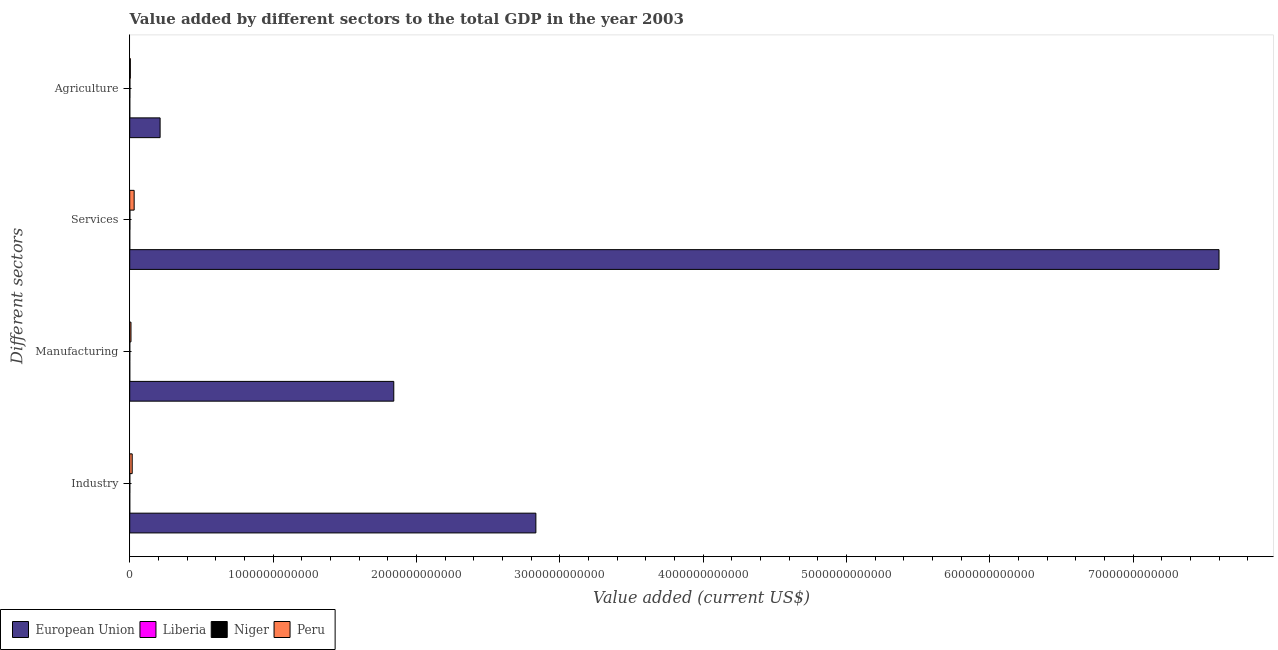Are the number of bars per tick equal to the number of legend labels?
Provide a short and direct response. Yes. What is the label of the 1st group of bars from the top?
Ensure brevity in your answer.  Agriculture. What is the value added by manufacturing sector in Niger?
Offer a very short reply. 1.73e+08. Across all countries, what is the maximum value added by agricultural sector?
Your answer should be very brief. 2.12e+11. Across all countries, what is the minimum value added by agricultural sector?
Your answer should be very brief. 3.01e+08. In which country was the value added by industrial sector minimum?
Your response must be concise. Liberia. What is the total value added by manufacturing sector in the graph?
Make the answer very short. 1.85e+12. What is the difference between the value added by services sector in Peru and that in European Union?
Provide a short and direct response. -7.57e+12. What is the difference between the value added by industrial sector in European Union and the value added by manufacturing sector in Niger?
Keep it short and to the point. 2.83e+12. What is the average value added by agricultural sector per country?
Your answer should be very brief. 5.44e+1. What is the difference between the value added by manufacturing sector and value added by services sector in Peru?
Offer a terse response. -2.21e+1. In how many countries, is the value added by services sector greater than 5400000000000 US$?
Ensure brevity in your answer.  1. What is the ratio of the value added by agricultural sector in Liberia to that in Niger?
Your response must be concise. 0.28. Is the value added by manufacturing sector in Niger less than that in Liberia?
Offer a terse response. No. What is the difference between the highest and the second highest value added by agricultural sector?
Your answer should be very brief. 2.08e+11. What is the difference between the highest and the lowest value added by industrial sector?
Offer a very short reply. 2.83e+12. What does the 3rd bar from the top in Manufacturing represents?
Provide a short and direct response. Liberia. What does the 2nd bar from the bottom in Agriculture represents?
Provide a short and direct response. Liberia. How many countries are there in the graph?
Provide a succinct answer. 4. What is the difference between two consecutive major ticks on the X-axis?
Keep it short and to the point. 1.00e+12. Does the graph contain any zero values?
Your answer should be very brief. No. Does the graph contain grids?
Keep it short and to the point. No. Where does the legend appear in the graph?
Make the answer very short. Bottom left. What is the title of the graph?
Give a very brief answer. Value added by different sectors to the total GDP in the year 2003. Does "OECD members" appear as one of the legend labels in the graph?
Keep it short and to the point. No. What is the label or title of the X-axis?
Provide a succinct answer. Value added (current US$). What is the label or title of the Y-axis?
Your answer should be compact. Different sectors. What is the Value added (current US$) in European Union in Industry?
Offer a terse response. 2.83e+12. What is the Value added (current US$) in Liberia in Industry?
Your answer should be very brief. 1.73e+07. What is the Value added (current US$) of Niger in Industry?
Your response must be concise. 4.68e+08. What is the Value added (current US$) of Peru in Industry?
Provide a succinct answer. 1.73e+1. What is the Value added (current US$) in European Union in Manufacturing?
Offer a terse response. 1.84e+12. What is the Value added (current US$) in Liberia in Manufacturing?
Offer a terse response. 1.69e+07. What is the Value added (current US$) in Niger in Manufacturing?
Your response must be concise. 1.73e+08. What is the Value added (current US$) in Peru in Manufacturing?
Ensure brevity in your answer.  8.81e+09. What is the Value added (current US$) of European Union in Services?
Make the answer very short. 7.60e+12. What is the Value added (current US$) in Liberia in Services?
Provide a short and direct response. 9.90e+07. What is the Value added (current US$) of Niger in Services?
Offer a terse response. 1.18e+09. What is the Value added (current US$) of Peru in Services?
Make the answer very short. 3.09e+1. What is the Value added (current US$) in European Union in Agriculture?
Offer a very short reply. 2.12e+11. What is the Value added (current US$) of Liberia in Agriculture?
Give a very brief answer. 3.01e+08. What is the Value added (current US$) in Niger in Agriculture?
Make the answer very short. 1.08e+09. What is the Value added (current US$) of Peru in Agriculture?
Offer a very short reply. 4.28e+09. Across all Different sectors, what is the maximum Value added (current US$) in European Union?
Keep it short and to the point. 7.60e+12. Across all Different sectors, what is the maximum Value added (current US$) of Liberia?
Your response must be concise. 3.01e+08. Across all Different sectors, what is the maximum Value added (current US$) of Niger?
Your response must be concise. 1.18e+09. Across all Different sectors, what is the maximum Value added (current US$) in Peru?
Ensure brevity in your answer.  3.09e+1. Across all Different sectors, what is the minimum Value added (current US$) of European Union?
Keep it short and to the point. 2.12e+11. Across all Different sectors, what is the minimum Value added (current US$) in Liberia?
Your answer should be very brief. 1.69e+07. Across all Different sectors, what is the minimum Value added (current US$) of Niger?
Your response must be concise. 1.73e+08. Across all Different sectors, what is the minimum Value added (current US$) of Peru?
Provide a short and direct response. 4.28e+09. What is the total Value added (current US$) in European Union in the graph?
Your answer should be compact. 1.25e+13. What is the total Value added (current US$) in Liberia in the graph?
Your response must be concise. 4.34e+08. What is the total Value added (current US$) of Niger in the graph?
Provide a short and direct response. 2.90e+09. What is the total Value added (current US$) in Peru in the graph?
Give a very brief answer. 6.13e+1. What is the difference between the Value added (current US$) in European Union in Industry and that in Manufacturing?
Offer a very short reply. 9.91e+11. What is the difference between the Value added (current US$) of Liberia in Industry and that in Manufacturing?
Keep it short and to the point. 3.84e+05. What is the difference between the Value added (current US$) in Niger in Industry and that in Manufacturing?
Your response must be concise. 2.94e+08. What is the difference between the Value added (current US$) of Peru in Industry and that in Manufacturing?
Give a very brief answer. 8.50e+09. What is the difference between the Value added (current US$) in European Union in Industry and that in Services?
Your answer should be compact. -4.77e+12. What is the difference between the Value added (current US$) in Liberia in Industry and that in Services?
Your response must be concise. -8.17e+07. What is the difference between the Value added (current US$) of Niger in Industry and that in Services?
Your answer should be compact. -7.13e+08. What is the difference between the Value added (current US$) of Peru in Industry and that in Services?
Offer a very short reply. -1.36e+1. What is the difference between the Value added (current US$) of European Union in Industry and that in Agriculture?
Your response must be concise. 2.62e+12. What is the difference between the Value added (current US$) in Liberia in Industry and that in Agriculture?
Offer a terse response. -2.83e+08. What is the difference between the Value added (current US$) in Niger in Industry and that in Agriculture?
Offer a very short reply. -6.15e+08. What is the difference between the Value added (current US$) in Peru in Industry and that in Agriculture?
Make the answer very short. 1.30e+1. What is the difference between the Value added (current US$) of European Union in Manufacturing and that in Services?
Keep it short and to the point. -5.76e+12. What is the difference between the Value added (current US$) of Liberia in Manufacturing and that in Services?
Make the answer very short. -8.21e+07. What is the difference between the Value added (current US$) of Niger in Manufacturing and that in Services?
Keep it short and to the point. -1.01e+09. What is the difference between the Value added (current US$) of Peru in Manufacturing and that in Services?
Your answer should be compact. -2.21e+1. What is the difference between the Value added (current US$) in European Union in Manufacturing and that in Agriculture?
Keep it short and to the point. 1.63e+12. What is the difference between the Value added (current US$) of Liberia in Manufacturing and that in Agriculture?
Your answer should be very brief. -2.84e+08. What is the difference between the Value added (current US$) of Niger in Manufacturing and that in Agriculture?
Your response must be concise. -9.09e+08. What is the difference between the Value added (current US$) in Peru in Manufacturing and that in Agriculture?
Offer a terse response. 4.53e+09. What is the difference between the Value added (current US$) in European Union in Services and that in Agriculture?
Offer a terse response. 7.39e+12. What is the difference between the Value added (current US$) of Liberia in Services and that in Agriculture?
Keep it short and to the point. -2.02e+08. What is the difference between the Value added (current US$) in Niger in Services and that in Agriculture?
Keep it short and to the point. 9.79e+07. What is the difference between the Value added (current US$) in Peru in Services and that in Agriculture?
Make the answer very short. 2.66e+1. What is the difference between the Value added (current US$) in European Union in Industry and the Value added (current US$) in Liberia in Manufacturing?
Keep it short and to the point. 2.83e+12. What is the difference between the Value added (current US$) in European Union in Industry and the Value added (current US$) in Niger in Manufacturing?
Your answer should be compact. 2.83e+12. What is the difference between the Value added (current US$) in European Union in Industry and the Value added (current US$) in Peru in Manufacturing?
Offer a terse response. 2.82e+12. What is the difference between the Value added (current US$) in Liberia in Industry and the Value added (current US$) in Niger in Manufacturing?
Provide a short and direct response. -1.56e+08. What is the difference between the Value added (current US$) in Liberia in Industry and the Value added (current US$) in Peru in Manufacturing?
Offer a very short reply. -8.79e+09. What is the difference between the Value added (current US$) of Niger in Industry and the Value added (current US$) of Peru in Manufacturing?
Ensure brevity in your answer.  -8.34e+09. What is the difference between the Value added (current US$) in European Union in Industry and the Value added (current US$) in Liberia in Services?
Give a very brief answer. 2.83e+12. What is the difference between the Value added (current US$) of European Union in Industry and the Value added (current US$) of Niger in Services?
Offer a very short reply. 2.83e+12. What is the difference between the Value added (current US$) of European Union in Industry and the Value added (current US$) of Peru in Services?
Provide a short and direct response. 2.80e+12. What is the difference between the Value added (current US$) of Liberia in Industry and the Value added (current US$) of Niger in Services?
Give a very brief answer. -1.16e+09. What is the difference between the Value added (current US$) in Liberia in Industry and the Value added (current US$) in Peru in Services?
Your answer should be very brief. -3.09e+1. What is the difference between the Value added (current US$) of Niger in Industry and the Value added (current US$) of Peru in Services?
Keep it short and to the point. -3.04e+1. What is the difference between the Value added (current US$) in European Union in Industry and the Value added (current US$) in Liberia in Agriculture?
Your response must be concise. 2.83e+12. What is the difference between the Value added (current US$) of European Union in Industry and the Value added (current US$) of Niger in Agriculture?
Provide a succinct answer. 2.83e+12. What is the difference between the Value added (current US$) in European Union in Industry and the Value added (current US$) in Peru in Agriculture?
Your response must be concise. 2.83e+12. What is the difference between the Value added (current US$) of Liberia in Industry and the Value added (current US$) of Niger in Agriculture?
Offer a terse response. -1.07e+09. What is the difference between the Value added (current US$) in Liberia in Industry and the Value added (current US$) in Peru in Agriculture?
Make the answer very short. -4.27e+09. What is the difference between the Value added (current US$) of Niger in Industry and the Value added (current US$) of Peru in Agriculture?
Ensure brevity in your answer.  -3.82e+09. What is the difference between the Value added (current US$) in European Union in Manufacturing and the Value added (current US$) in Liberia in Services?
Ensure brevity in your answer.  1.84e+12. What is the difference between the Value added (current US$) of European Union in Manufacturing and the Value added (current US$) of Niger in Services?
Provide a short and direct response. 1.84e+12. What is the difference between the Value added (current US$) in European Union in Manufacturing and the Value added (current US$) in Peru in Services?
Ensure brevity in your answer.  1.81e+12. What is the difference between the Value added (current US$) in Liberia in Manufacturing and the Value added (current US$) in Niger in Services?
Your answer should be very brief. -1.16e+09. What is the difference between the Value added (current US$) in Liberia in Manufacturing and the Value added (current US$) in Peru in Services?
Ensure brevity in your answer.  -3.09e+1. What is the difference between the Value added (current US$) of Niger in Manufacturing and the Value added (current US$) of Peru in Services?
Keep it short and to the point. -3.07e+1. What is the difference between the Value added (current US$) of European Union in Manufacturing and the Value added (current US$) of Liberia in Agriculture?
Make the answer very short. 1.84e+12. What is the difference between the Value added (current US$) of European Union in Manufacturing and the Value added (current US$) of Niger in Agriculture?
Keep it short and to the point. 1.84e+12. What is the difference between the Value added (current US$) in European Union in Manufacturing and the Value added (current US$) in Peru in Agriculture?
Offer a very short reply. 1.84e+12. What is the difference between the Value added (current US$) in Liberia in Manufacturing and the Value added (current US$) in Niger in Agriculture?
Your answer should be very brief. -1.07e+09. What is the difference between the Value added (current US$) in Liberia in Manufacturing and the Value added (current US$) in Peru in Agriculture?
Your answer should be very brief. -4.27e+09. What is the difference between the Value added (current US$) of Niger in Manufacturing and the Value added (current US$) of Peru in Agriculture?
Your answer should be compact. -4.11e+09. What is the difference between the Value added (current US$) in European Union in Services and the Value added (current US$) in Liberia in Agriculture?
Your answer should be very brief. 7.60e+12. What is the difference between the Value added (current US$) of European Union in Services and the Value added (current US$) of Niger in Agriculture?
Ensure brevity in your answer.  7.60e+12. What is the difference between the Value added (current US$) in European Union in Services and the Value added (current US$) in Peru in Agriculture?
Keep it short and to the point. 7.60e+12. What is the difference between the Value added (current US$) in Liberia in Services and the Value added (current US$) in Niger in Agriculture?
Keep it short and to the point. -9.84e+08. What is the difference between the Value added (current US$) of Liberia in Services and the Value added (current US$) of Peru in Agriculture?
Keep it short and to the point. -4.19e+09. What is the difference between the Value added (current US$) in Niger in Services and the Value added (current US$) in Peru in Agriculture?
Provide a succinct answer. -3.10e+09. What is the average Value added (current US$) of European Union per Different sectors?
Give a very brief answer. 3.12e+12. What is the average Value added (current US$) in Liberia per Different sectors?
Offer a very short reply. 1.08e+08. What is the average Value added (current US$) in Niger per Different sectors?
Your response must be concise. 7.26e+08. What is the average Value added (current US$) of Peru per Different sectors?
Make the answer very short. 1.53e+1. What is the difference between the Value added (current US$) of European Union and Value added (current US$) of Liberia in Industry?
Ensure brevity in your answer.  2.83e+12. What is the difference between the Value added (current US$) in European Union and Value added (current US$) in Niger in Industry?
Your answer should be very brief. 2.83e+12. What is the difference between the Value added (current US$) of European Union and Value added (current US$) of Peru in Industry?
Your answer should be very brief. 2.82e+12. What is the difference between the Value added (current US$) of Liberia and Value added (current US$) of Niger in Industry?
Your response must be concise. -4.50e+08. What is the difference between the Value added (current US$) in Liberia and Value added (current US$) in Peru in Industry?
Give a very brief answer. -1.73e+1. What is the difference between the Value added (current US$) in Niger and Value added (current US$) in Peru in Industry?
Keep it short and to the point. -1.68e+1. What is the difference between the Value added (current US$) of European Union and Value added (current US$) of Liberia in Manufacturing?
Your response must be concise. 1.84e+12. What is the difference between the Value added (current US$) of European Union and Value added (current US$) of Niger in Manufacturing?
Offer a very short reply. 1.84e+12. What is the difference between the Value added (current US$) in European Union and Value added (current US$) in Peru in Manufacturing?
Keep it short and to the point. 1.83e+12. What is the difference between the Value added (current US$) of Liberia and Value added (current US$) of Niger in Manufacturing?
Provide a short and direct response. -1.57e+08. What is the difference between the Value added (current US$) in Liberia and Value added (current US$) in Peru in Manufacturing?
Provide a succinct answer. -8.79e+09. What is the difference between the Value added (current US$) of Niger and Value added (current US$) of Peru in Manufacturing?
Provide a succinct answer. -8.64e+09. What is the difference between the Value added (current US$) in European Union and Value added (current US$) in Liberia in Services?
Your response must be concise. 7.60e+12. What is the difference between the Value added (current US$) of European Union and Value added (current US$) of Niger in Services?
Your answer should be compact. 7.60e+12. What is the difference between the Value added (current US$) of European Union and Value added (current US$) of Peru in Services?
Offer a terse response. 7.57e+12. What is the difference between the Value added (current US$) in Liberia and Value added (current US$) in Niger in Services?
Offer a terse response. -1.08e+09. What is the difference between the Value added (current US$) in Liberia and Value added (current US$) in Peru in Services?
Ensure brevity in your answer.  -3.08e+1. What is the difference between the Value added (current US$) of Niger and Value added (current US$) of Peru in Services?
Your response must be concise. -2.97e+1. What is the difference between the Value added (current US$) of European Union and Value added (current US$) of Liberia in Agriculture?
Offer a terse response. 2.12e+11. What is the difference between the Value added (current US$) in European Union and Value added (current US$) in Niger in Agriculture?
Make the answer very short. 2.11e+11. What is the difference between the Value added (current US$) in European Union and Value added (current US$) in Peru in Agriculture?
Give a very brief answer. 2.08e+11. What is the difference between the Value added (current US$) of Liberia and Value added (current US$) of Niger in Agriculture?
Provide a succinct answer. -7.82e+08. What is the difference between the Value added (current US$) in Liberia and Value added (current US$) in Peru in Agriculture?
Give a very brief answer. -3.98e+09. What is the difference between the Value added (current US$) in Niger and Value added (current US$) in Peru in Agriculture?
Give a very brief answer. -3.20e+09. What is the ratio of the Value added (current US$) of European Union in Industry to that in Manufacturing?
Make the answer very short. 1.54. What is the ratio of the Value added (current US$) of Liberia in Industry to that in Manufacturing?
Provide a short and direct response. 1.02. What is the ratio of the Value added (current US$) of Niger in Industry to that in Manufacturing?
Make the answer very short. 2.7. What is the ratio of the Value added (current US$) in Peru in Industry to that in Manufacturing?
Offer a terse response. 1.96. What is the ratio of the Value added (current US$) in European Union in Industry to that in Services?
Give a very brief answer. 0.37. What is the ratio of the Value added (current US$) of Liberia in Industry to that in Services?
Make the answer very short. 0.17. What is the ratio of the Value added (current US$) in Niger in Industry to that in Services?
Make the answer very short. 0.4. What is the ratio of the Value added (current US$) of Peru in Industry to that in Services?
Give a very brief answer. 0.56. What is the ratio of the Value added (current US$) of European Union in Industry to that in Agriculture?
Offer a terse response. 13.37. What is the ratio of the Value added (current US$) of Liberia in Industry to that in Agriculture?
Give a very brief answer. 0.06. What is the ratio of the Value added (current US$) of Niger in Industry to that in Agriculture?
Your answer should be compact. 0.43. What is the ratio of the Value added (current US$) in Peru in Industry to that in Agriculture?
Offer a very short reply. 4.04. What is the ratio of the Value added (current US$) in European Union in Manufacturing to that in Services?
Your answer should be compact. 0.24. What is the ratio of the Value added (current US$) of Liberia in Manufacturing to that in Services?
Offer a very short reply. 0.17. What is the ratio of the Value added (current US$) of Niger in Manufacturing to that in Services?
Ensure brevity in your answer.  0.15. What is the ratio of the Value added (current US$) in Peru in Manufacturing to that in Services?
Offer a very short reply. 0.29. What is the ratio of the Value added (current US$) of European Union in Manufacturing to that in Agriculture?
Offer a terse response. 8.69. What is the ratio of the Value added (current US$) of Liberia in Manufacturing to that in Agriculture?
Provide a succinct answer. 0.06. What is the ratio of the Value added (current US$) in Niger in Manufacturing to that in Agriculture?
Provide a succinct answer. 0.16. What is the ratio of the Value added (current US$) in Peru in Manufacturing to that in Agriculture?
Offer a very short reply. 2.06. What is the ratio of the Value added (current US$) in European Union in Services to that in Agriculture?
Provide a short and direct response. 35.86. What is the ratio of the Value added (current US$) of Liberia in Services to that in Agriculture?
Provide a succinct answer. 0.33. What is the ratio of the Value added (current US$) of Niger in Services to that in Agriculture?
Offer a very short reply. 1.09. What is the ratio of the Value added (current US$) of Peru in Services to that in Agriculture?
Provide a short and direct response. 7.21. What is the difference between the highest and the second highest Value added (current US$) in European Union?
Provide a short and direct response. 4.77e+12. What is the difference between the highest and the second highest Value added (current US$) in Liberia?
Give a very brief answer. 2.02e+08. What is the difference between the highest and the second highest Value added (current US$) of Niger?
Your response must be concise. 9.79e+07. What is the difference between the highest and the second highest Value added (current US$) of Peru?
Your answer should be very brief. 1.36e+1. What is the difference between the highest and the lowest Value added (current US$) of European Union?
Your response must be concise. 7.39e+12. What is the difference between the highest and the lowest Value added (current US$) in Liberia?
Your response must be concise. 2.84e+08. What is the difference between the highest and the lowest Value added (current US$) in Niger?
Your answer should be very brief. 1.01e+09. What is the difference between the highest and the lowest Value added (current US$) of Peru?
Provide a succinct answer. 2.66e+1. 